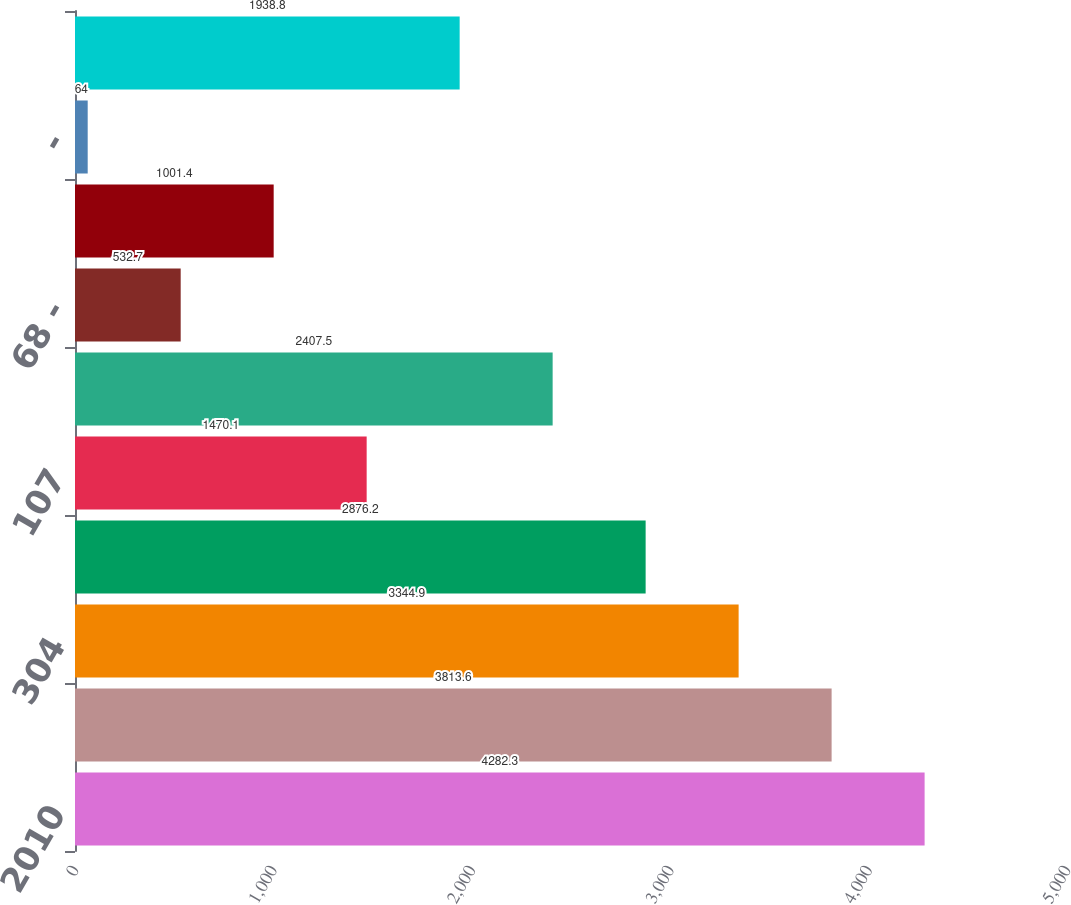Convert chart to OTSL. <chart><loc_0><loc_0><loc_500><loc_500><bar_chart><fcel>2010<fcel>448<fcel>304<fcel>303<fcel>107<fcel>209<fcel>68 -<fcel>2<fcel>-<fcel>- 220<nl><fcel>4282.3<fcel>3813.6<fcel>3344.9<fcel>2876.2<fcel>1470.1<fcel>2407.5<fcel>532.7<fcel>1001.4<fcel>64<fcel>1938.8<nl></chart> 